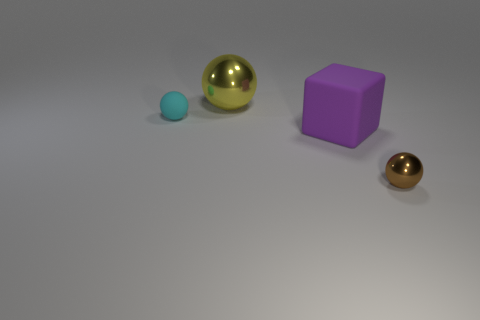Is the number of green rubber blocks greater than the number of big purple matte blocks?
Give a very brief answer. No. What size is the rubber object that is to the right of the small ball that is left of the shiny object that is in front of the small cyan sphere?
Provide a short and direct response. Large. There is a metal ball in front of the small cyan ball; what size is it?
Make the answer very short. Small. What number of objects are either shiny spheres or balls that are behind the small matte thing?
Offer a very short reply. 2. What number of other objects are there of the same size as the brown shiny ball?
Make the answer very short. 1. What is the material of the cyan object that is the same shape as the brown metallic object?
Keep it short and to the point. Rubber. Are there more tiny cyan rubber objects behind the small cyan rubber sphere than metal things?
Provide a short and direct response. No. Is there any other thing that has the same color as the big metal ball?
Give a very brief answer. No. There is a object that is made of the same material as the tiny brown ball; what is its shape?
Your answer should be very brief. Sphere. Does the small thing that is behind the brown ball have the same material as the brown thing?
Ensure brevity in your answer.  No. 